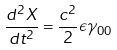Convert formula to latex. <formula><loc_0><loc_0><loc_500><loc_500>\frac { d ^ { 2 } X } { d t ^ { 2 } } = \frac { c ^ { 2 } } { 2 } \epsilon \gamma _ { 0 0 }</formula> 